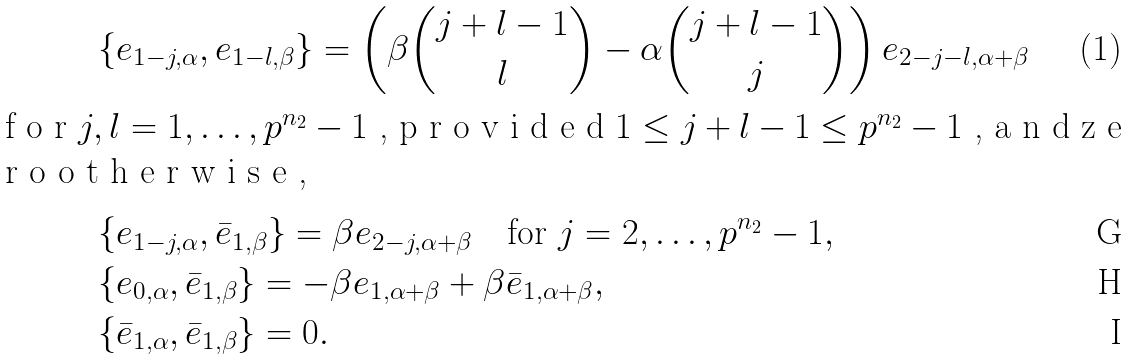<formula> <loc_0><loc_0><loc_500><loc_500>& \{ e _ { 1 - j , \alpha } , e _ { 1 - l , \beta } \} = \left ( \beta \binom { j + l - 1 } { l } - \alpha \binom { j + l - 1 } { j } \right ) e _ { 2 - j - l , \alpha + \beta } \intertext { f o r $ j , l = 1 , \dots , p ^ { n _ { 2 } } - 1 $ , p r o v i d e d $ 1 \leq j + l - 1 \leq p ^ { n _ { 2 } } - 1 $ , a n d z e r o o t h e r w i s e , } & \{ e _ { 1 - j , \alpha } , \bar { e } _ { 1 , \beta } \} = \beta e _ { 2 - j , \alpha + \beta } \quad \text {for $j=2,\dots,p^{n_{2}}-1$} , \\ & \{ e _ { 0 , \alpha } , \bar { e } _ { 1 , \beta } \} = - \beta e _ { 1 , \alpha + \beta } + \beta \bar { e } _ { 1 , \alpha + \beta } , \\ & \{ \bar { e } _ { 1 , \alpha } , \bar { e } _ { 1 , \beta } \} = 0 .</formula> 